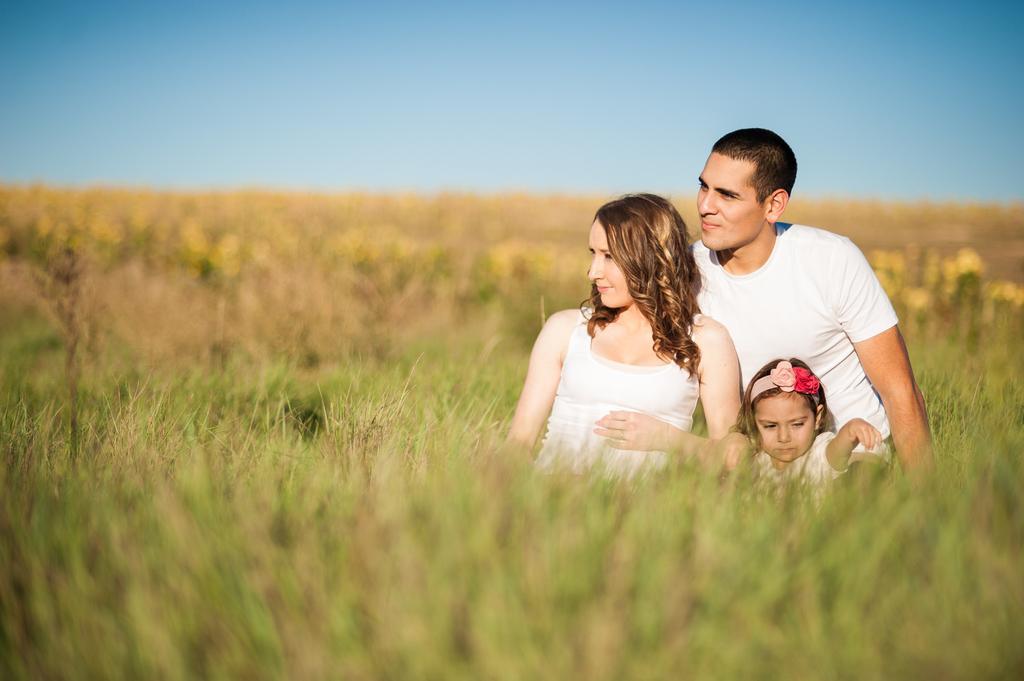How would you summarize this image in a sentence or two? Here we can see a woman, man, and a kid on the ground. This is grass. In the background we can see sky. 